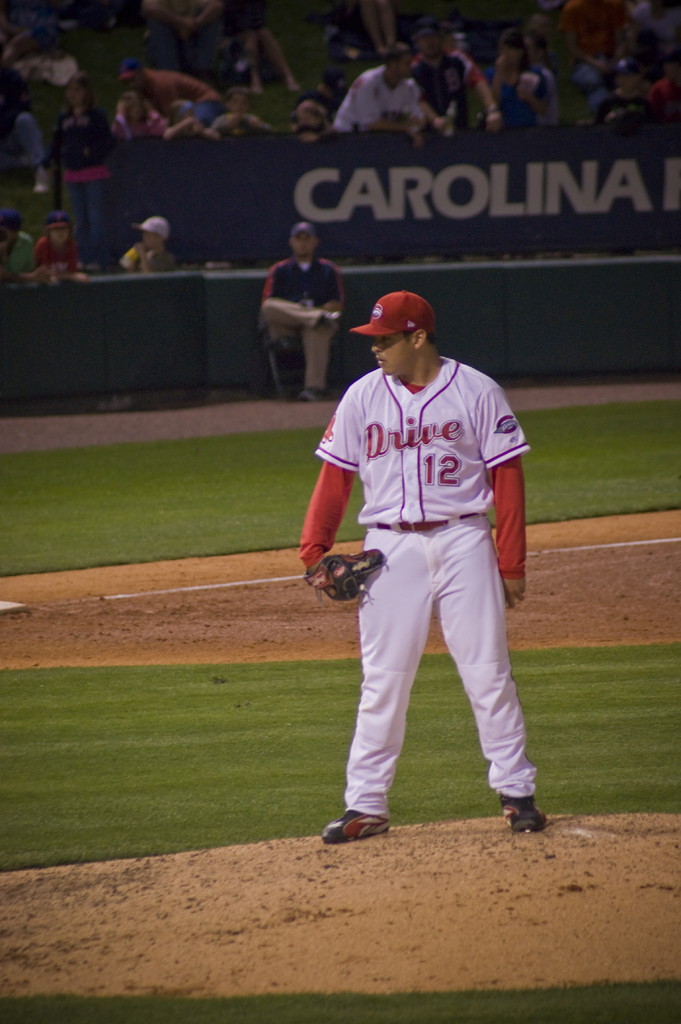What position might this player hold, given the context of the image? The player appears to be a pitcher, evident from his presence on the pitching mound and his posture, which suggests readiness to throw a pitch. 